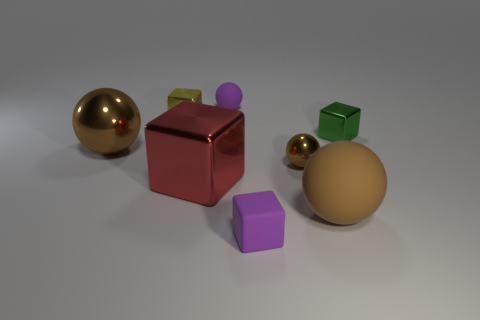Subtract all purple blocks. How many brown balls are left? 3 Subtract all cyan balls. Subtract all purple blocks. How many balls are left? 4 Add 1 large gray rubber objects. How many objects exist? 9 Add 8 rubber spheres. How many rubber spheres are left? 10 Add 8 small rubber balls. How many small rubber balls exist? 9 Subtract 0 blue balls. How many objects are left? 8 Subtract all yellow rubber spheres. Subtract all small purple cubes. How many objects are left? 7 